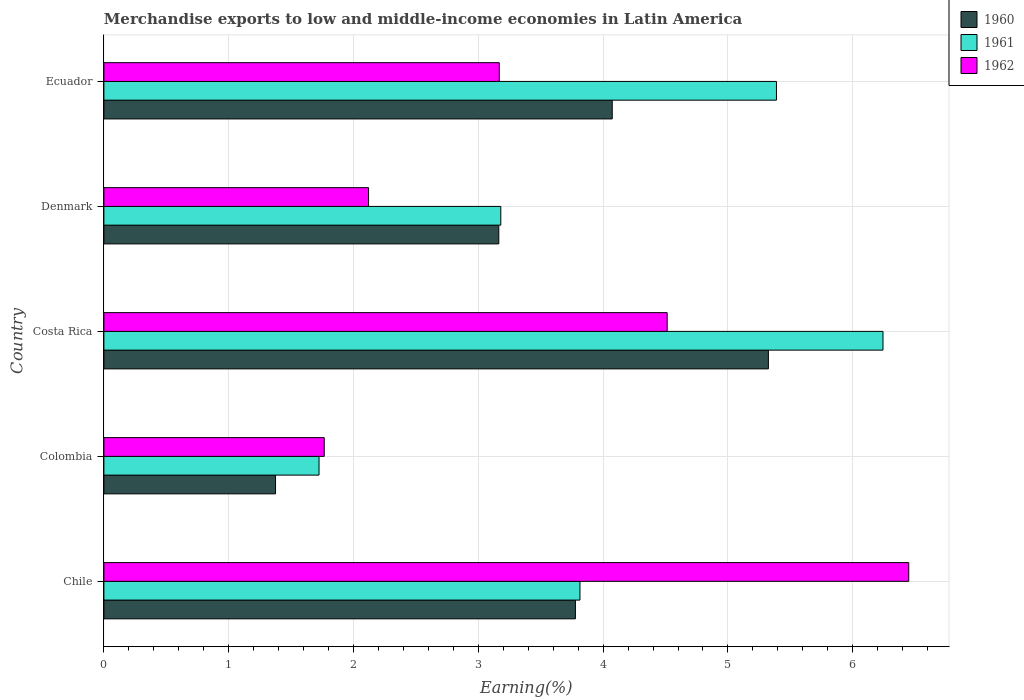How many different coloured bars are there?
Your response must be concise. 3. Are the number of bars on each tick of the Y-axis equal?
Keep it short and to the point. Yes. How many bars are there on the 3rd tick from the bottom?
Provide a succinct answer. 3. In how many cases, is the number of bars for a given country not equal to the number of legend labels?
Provide a short and direct response. 0. What is the percentage of amount earned from merchandise exports in 1962 in Chile?
Keep it short and to the point. 6.45. Across all countries, what is the maximum percentage of amount earned from merchandise exports in 1962?
Your answer should be very brief. 6.45. Across all countries, what is the minimum percentage of amount earned from merchandise exports in 1960?
Ensure brevity in your answer.  1.38. In which country was the percentage of amount earned from merchandise exports in 1962 maximum?
Your answer should be very brief. Chile. In which country was the percentage of amount earned from merchandise exports in 1961 minimum?
Your answer should be very brief. Colombia. What is the total percentage of amount earned from merchandise exports in 1960 in the graph?
Your answer should be compact. 17.71. What is the difference between the percentage of amount earned from merchandise exports in 1961 in Colombia and that in Costa Rica?
Your response must be concise. -4.52. What is the difference between the percentage of amount earned from merchandise exports in 1961 in Costa Rica and the percentage of amount earned from merchandise exports in 1962 in Ecuador?
Your response must be concise. 3.07. What is the average percentage of amount earned from merchandise exports in 1960 per country?
Your answer should be compact. 3.54. What is the difference between the percentage of amount earned from merchandise exports in 1962 and percentage of amount earned from merchandise exports in 1961 in Denmark?
Offer a terse response. -1.06. What is the ratio of the percentage of amount earned from merchandise exports in 1960 in Denmark to that in Ecuador?
Give a very brief answer. 0.78. Is the percentage of amount earned from merchandise exports in 1960 in Costa Rica less than that in Denmark?
Offer a terse response. No. Is the difference between the percentage of amount earned from merchandise exports in 1962 in Chile and Denmark greater than the difference between the percentage of amount earned from merchandise exports in 1961 in Chile and Denmark?
Offer a terse response. Yes. What is the difference between the highest and the second highest percentage of amount earned from merchandise exports in 1960?
Offer a terse response. 1.25. What is the difference between the highest and the lowest percentage of amount earned from merchandise exports in 1960?
Ensure brevity in your answer.  3.95. Is the sum of the percentage of amount earned from merchandise exports in 1962 in Denmark and Ecuador greater than the maximum percentage of amount earned from merchandise exports in 1960 across all countries?
Give a very brief answer. No. What does the 3rd bar from the top in Costa Rica represents?
Your response must be concise. 1960. What does the 2nd bar from the bottom in Colombia represents?
Keep it short and to the point. 1961. Is it the case that in every country, the sum of the percentage of amount earned from merchandise exports in 1960 and percentage of amount earned from merchandise exports in 1962 is greater than the percentage of amount earned from merchandise exports in 1961?
Provide a succinct answer. Yes. How many bars are there?
Offer a very short reply. 15. How many countries are there in the graph?
Make the answer very short. 5. Does the graph contain any zero values?
Ensure brevity in your answer.  No. Does the graph contain grids?
Give a very brief answer. Yes. Where does the legend appear in the graph?
Provide a succinct answer. Top right. What is the title of the graph?
Provide a succinct answer. Merchandise exports to low and middle-income economies in Latin America. What is the label or title of the X-axis?
Provide a succinct answer. Earning(%). What is the Earning(%) of 1960 in Chile?
Give a very brief answer. 3.78. What is the Earning(%) of 1961 in Chile?
Provide a succinct answer. 3.81. What is the Earning(%) of 1962 in Chile?
Provide a short and direct response. 6.45. What is the Earning(%) of 1960 in Colombia?
Provide a short and direct response. 1.38. What is the Earning(%) of 1961 in Colombia?
Provide a succinct answer. 1.72. What is the Earning(%) in 1962 in Colombia?
Offer a terse response. 1.77. What is the Earning(%) of 1960 in Costa Rica?
Give a very brief answer. 5.32. What is the Earning(%) in 1961 in Costa Rica?
Your answer should be compact. 6.24. What is the Earning(%) in 1962 in Costa Rica?
Your response must be concise. 4.51. What is the Earning(%) in 1960 in Denmark?
Offer a very short reply. 3.16. What is the Earning(%) of 1961 in Denmark?
Keep it short and to the point. 3.18. What is the Earning(%) of 1962 in Denmark?
Keep it short and to the point. 2.12. What is the Earning(%) of 1960 in Ecuador?
Offer a terse response. 4.07. What is the Earning(%) of 1961 in Ecuador?
Your answer should be very brief. 5.39. What is the Earning(%) of 1962 in Ecuador?
Provide a succinct answer. 3.17. Across all countries, what is the maximum Earning(%) in 1960?
Provide a succinct answer. 5.32. Across all countries, what is the maximum Earning(%) in 1961?
Your response must be concise. 6.24. Across all countries, what is the maximum Earning(%) of 1962?
Your answer should be compact. 6.45. Across all countries, what is the minimum Earning(%) in 1960?
Offer a very short reply. 1.38. Across all countries, what is the minimum Earning(%) of 1961?
Keep it short and to the point. 1.72. Across all countries, what is the minimum Earning(%) in 1962?
Offer a terse response. 1.77. What is the total Earning(%) in 1960 in the graph?
Offer a terse response. 17.71. What is the total Earning(%) in 1961 in the graph?
Ensure brevity in your answer.  20.35. What is the total Earning(%) of 1962 in the graph?
Ensure brevity in your answer.  18.02. What is the difference between the Earning(%) of 1960 in Chile and that in Colombia?
Provide a succinct answer. 2.4. What is the difference between the Earning(%) of 1961 in Chile and that in Colombia?
Offer a terse response. 2.09. What is the difference between the Earning(%) of 1962 in Chile and that in Colombia?
Provide a short and direct response. 4.68. What is the difference between the Earning(%) of 1960 in Chile and that in Costa Rica?
Your response must be concise. -1.55. What is the difference between the Earning(%) in 1961 in Chile and that in Costa Rica?
Offer a very short reply. -2.43. What is the difference between the Earning(%) in 1962 in Chile and that in Costa Rica?
Your answer should be very brief. 1.94. What is the difference between the Earning(%) of 1960 in Chile and that in Denmark?
Your answer should be very brief. 0.61. What is the difference between the Earning(%) of 1961 in Chile and that in Denmark?
Give a very brief answer. 0.63. What is the difference between the Earning(%) in 1962 in Chile and that in Denmark?
Offer a very short reply. 4.33. What is the difference between the Earning(%) of 1960 in Chile and that in Ecuador?
Your answer should be compact. -0.3. What is the difference between the Earning(%) of 1961 in Chile and that in Ecuador?
Provide a succinct answer. -1.57. What is the difference between the Earning(%) in 1962 in Chile and that in Ecuador?
Provide a short and direct response. 3.28. What is the difference between the Earning(%) in 1960 in Colombia and that in Costa Rica?
Give a very brief answer. -3.95. What is the difference between the Earning(%) of 1961 in Colombia and that in Costa Rica?
Ensure brevity in your answer.  -4.52. What is the difference between the Earning(%) of 1962 in Colombia and that in Costa Rica?
Your answer should be compact. -2.75. What is the difference between the Earning(%) in 1960 in Colombia and that in Denmark?
Your answer should be very brief. -1.79. What is the difference between the Earning(%) in 1961 in Colombia and that in Denmark?
Provide a succinct answer. -1.46. What is the difference between the Earning(%) of 1962 in Colombia and that in Denmark?
Your response must be concise. -0.36. What is the difference between the Earning(%) of 1960 in Colombia and that in Ecuador?
Your answer should be very brief. -2.7. What is the difference between the Earning(%) in 1961 in Colombia and that in Ecuador?
Provide a short and direct response. -3.66. What is the difference between the Earning(%) of 1962 in Colombia and that in Ecuador?
Give a very brief answer. -1.4. What is the difference between the Earning(%) in 1960 in Costa Rica and that in Denmark?
Offer a very short reply. 2.16. What is the difference between the Earning(%) in 1961 in Costa Rica and that in Denmark?
Your response must be concise. 3.06. What is the difference between the Earning(%) of 1962 in Costa Rica and that in Denmark?
Your response must be concise. 2.39. What is the difference between the Earning(%) of 1960 in Costa Rica and that in Ecuador?
Make the answer very short. 1.25. What is the difference between the Earning(%) in 1961 in Costa Rica and that in Ecuador?
Give a very brief answer. 0.85. What is the difference between the Earning(%) of 1962 in Costa Rica and that in Ecuador?
Offer a terse response. 1.35. What is the difference between the Earning(%) of 1960 in Denmark and that in Ecuador?
Offer a terse response. -0.91. What is the difference between the Earning(%) in 1961 in Denmark and that in Ecuador?
Provide a succinct answer. -2.21. What is the difference between the Earning(%) in 1962 in Denmark and that in Ecuador?
Provide a short and direct response. -1.05. What is the difference between the Earning(%) in 1960 in Chile and the Earning(%) in 1961 in Colombia?
Your answer should be very brief. 2.05. What is the difference between the Earning(%) of 1960 in Chile and the Earning(%) of 1962 in Colombia?
Give a very brief answer. 2.01. What is the difference between the Earning(%) of 1961 in Chile and the Earning(%) of 1962 in Colombia?
Keep it short and to the point. 2.05. What is the difference between the Earning(%) of 1960 in Chile and the Earning(%) of 1961 in Costa Rica?
Your answer should be compact. -2.46. What is the difference between the Earning(%) of 1960 in Chile and the Earning(%) of 1962 in Costa Rica?
Provide a short and direct response. -0.74. What is the difference between the Earning(%) in 1961 in Chile and the Earning(%) in 1962 in Costa Rica?
Offer a terse response. -0.7. What is the difference between the Earning(%) in 1960 in Chile and the Earning(%) in 1961 in Denmark?
Your answer should be very brief. 0.6. What is the difference between the Earning(%) in 1960 in Chile and the Earning(%) in 1962 in Denmark?
Offer a very short reply. 1.66. What is the difference between the Earning(%) in 1961 in Chile and the Earning(%) in 1962 in Denmark?
Provide a succinct answer. 1.69. What is the difference between the Earning(%) in 1960 in Chile and the Earning(%) in 1961 in Ecuador?
Provide a short and direct response. -1.61. What is the difference between the Earning(%) of 1960 in Chile and the Earning(%) of 1962 in Ecuador?
Ensure brevity in your answer.  0.61. What is the difference between the Earning(%) in 1961 in Chile and the Earning(%) in 1962 in Ecuador?
Make the answer very short. 0.65. What is the difference between the Earning(%) in 1960 in Colombia and the Earning(%) in 1961 in Costa Rica?
Make the answer very short. -4.87. What is the difference between the Earning(%) of 1960 in Colombia and the Earning(%) of 1962 in Costa Rica?
Give a very brief answer. -3.14. What is the difference between the Earning(%) of 1961 in Colombia and the Earning(%) of 1962 in Costa Rica?
Offer a terse response. -2.79. What is the difference between the Earning(%) in 1960 in Colombia and the Earning(%) in 1961 in Denmark?
Keep it short and to the point. -1.8. What is the difference between the Earning(%) in 1960 in Colombia and the Earning(%) in 1962 in Denmark?
Your answer should be very brief. -0.75. What is the difference between the Earning(%) of 1961 in Colombia and the Earning(%) of 1962 in Denmark?
Keep it short and to the point. -0.4. What is the difference between the Earning(%) of 1960 in Colombia and the Earning(%) of 1961 in Ecuador?
Keep it short and to the point. -4.01. What is the difference between the Earning(%) of 1960 in Colombia and the Earning(%) of 1962 in Ecuador?
Ensure brevity in your answer.  -1.79. What is the difference between the Earning(%) of 1961 in Colombia and the Earning(%) of 1962 in Ecuador?
Your answer should be very brief. -1.44. What is the difference between the Earning(%) in 1960 in Costa Rica and the Earning(%) in 1961 in Denmark?
Give a very brief answer. 2.14. What is the difference between the Earning(%) of 1960 in Costa Rica and the Earning(%) of 1962 in Denmark?
Your response must be concise. 3.2. What is the difference between the Earning(%) in 1961 in Costa Rica and the Earning(%) in 1962 in Denmark?
Your answer should be very brief. 4.12. What is the difference between the Earning(%) in 1960 in Costa Rica and the Earning(%) in 1961 in Ecuador?
Offer a terse response. -0.06. What is the difference between the Earning(%) of 1960 in Costa Rica and the Earning(%) of 1962 in Ecuador?
Provide a short and direct response. 2.16. What is the difference between the Earning(%) in 1961 in Costa Rica and the Earning(%) in 1962 in Ecuador?
Offer a very short reply. 3.07. What is the difference between the Earning(%) in 1960 in Denmark and the Earning(%) in 1961 in Ecuador?
Keep it short and to the point. -2.22. What is the difference between the Earning(%) in 1960 in Denmark and the Earning(%) in 1962 in Ecuador?
Provide a short and direct response. -0. What is the difference between the Earning(%) in 1961 in Denmark and the Earning(%) in 1962 in Ecuador?
Your response must be concise. 0.01. What is the average Earning(%) of 1960 per country?
Your answer should be very brief. 3.54. What is the average Earning(%) of 1961 per country?
Your answer should be very brief. 4.07. What is the average Earning(%) in 1962 per country?
Offer a very short reply. 3.6. What is the difference between the Earning(%) in 1960 and Earning(%) in 1961 in Chile?
Provide a succinct answer. -0.04. What is the difference between the Earning(%) in 1960 and Earning(%) in 1962 in Chile?
Your answer should be very brief. -2.67. What is the difference between the Earning(%) of 1961 and Earning(%) of 1962 in Chile?
Offer a very short reply. -2.63. What is the difference between the Earning(%) of 1960 and Earning(%) of 1961 in Colombia?
Provide a short and direct response. -0.35. What is the difference between the Earning(%) in 1960 and Earning(%) in 1962 in Colombia?
Your answer should be very brief. -0.39. What is the difference between the Earning(%) in 1961 and Earning(%) in 1962 in Colombia?
Offer a very short reply. -0.04. What is the difference between the Earning(%) of 1960 and Earning(%) of 1961 in Costa Rica?
Your answer should be very brief. -0.92. What is the difference between the Earning(%) of 1960 and Earning(%) of 1962 in Costa Rica?
Provide a succinct answer. 0.81. What is the difference between the Earning(%) of 1961 and Earning(%) of 1962 in Costa Rica?
Offer a terse response. 1.73. What is the difference between the Earning(%) of 1960 and Earning(%) of 1961 in Denmark?
Your response must be concise. -0.02. What is the difference between the Earning(%) of 1960 and Earning(%) of 1962 in Denmark?
Keep it short and to the point. 1.04. What is the difference between the Earning(%) of 1961 and Earning(%) of 1962 in Denmark?
Offer a very short reply. 1.06. What is the difference between the Earning(%) in 1960 and Earning(%) in 1961 in Ecuador?
Your response must be concise. -1.32. What is the difference between the Earning(%) in 1960 and Earning(%) in 1962 in Ecuador?
Offer a terse response. 0.91. What is the difference between the Earning(%) of 1961 and Earning(%) of 1962 in Ecuador?
Give a very brief answer. 2.22. What is the ratio of the Earning(%) of 1960 in Chile to that in Colombia?
Your answer should be very brief. 2.75. What is the ratio of the Earning(%) in 1961 in Chile to that in Colombia?
Keep it short and to the point. 2.21. What is the ratio of the Earning(%) of 1962 in Chile to that in Colombia?
Offer a very short reply. 3.65. What is the ratio of the Earning(%) of 1960 in Chile to that in Costa Rica?
Provide a succinct answer. 0.71. What is the ratio of the Earning(%) in 1961 in Chile to that in Costa Rica?
Offer a terse response. 0.61. What is the ratio of the Earning(%) of 1962 in Chile to that in Costa Rica?
Your answer should be very brief. 1.43. What is the ratio of the Earning(%) in 1960 in Chile to that in Denmark?
Offer a very short reply. 1.19. What is the ratio of the Earning(%) in 1961 in Chile to that in Denmark?
Provide a succinct answer. 1.2. What is the ratio of the Earning(%) of 1962 in Chile to that in Denmark?
Provide a succinct answer. 3.04. What is the ratio of the Earning(%) of 1960 in Chile to that in Ecuador?
Give a very brief answer. 0.93. What is the ratio of the Earning(%) in 1961 in Chile to that in Ecuador?
Offer a terse response. 0.71. What is the ratio of the Earning(%) in 1962 in Chile to that in Ecuador?
Ensure brevity in your answer.  2.04. What is the ratio of the Earning(%) of 1960 in Colombia to that in Costa Rica?
Ensure brevity in your answer.  0.26. What is the ratio of the Earning(%) of 1961 in Colombia to that in Costa Rica?
Offer a terse response. 0.28. What is the ratio of the Earning(%) in 1962 in Colombia to that in Costa Rica?
Your answer should be compact. 0.39. What is the ratio of the Earning(%) in 1960 in Colombia to that in Denmark?
Your answer should be compact. 0.43. What is the ratio of the Earning(%) of 1961 in Colombia to that in Denmark?
Give a very brief answer. 0.54. What is the ratio of the Earning(%) of 1962 in Colombia to that in Denmark?
Your answer should be very brief. 0.83. What is the ratio of the Earning(%) of 1960 in Colombia to that in Ecuador?
Ensure brevity in your answer.  0.34. What is the ratio of the Earning(%) of 1961 in Colombia to that in Ecuador?
Give a very brief answer. 0.32. What is the ratio of the Earning(%) of 1962 in Colombia to that in Ecuador?
Give a very brief answer. 0.56. What is the ratio of the Earning(%) of 1960 in Costa Rica to that in Denmark?
Your answer should be compact. 1.68. What is the ratio of the Earning(%) in 1961 in Costa Rica to that in Denmark?
Your answer should be compact. 1.96. What is the ratio of the Earning(%) of 1962 in Costa Rica to that in Denmark?
Your response must be concise. 2.13. What is the ratio of the Earning(%) of 1960 in Costa Rica to that in Ecuador?
Offer a very short reply. 1.31. What is the ratio of the Earning(%) in 1961 in Costa Rica to that in Ecuador?
Keep it short and to the point. 1.16. What is the ratio of the Earning(%) in 1962 in Costa Rica to that in Ecuador?
Ensure brevity in your answer.  1.42. What is the ratio of the Earning(%) of 1960 in Denmark to that in Ecuador?
Your answer should be very brief. 0.78. What is the ratio of the Earning(%) of 1961 in Denmark to that in Ecuador?
Your answer should be very brief. 0.59. What is the ratio of the Earning(%) of 1962 in Denmark to that in Ecuador?
Your answer should be very brief. 0.67. What is the difference between the highest and the second highest Earning(%) of 1960?
Your response must be concise. 1.25. What is the difference between the highest and the second highest Earning(%) of 1961?
Offer a very short reply. 0.85. What is the difference between the highest and the second highest Earning(%) in 1962?
Your answer should be compact. 1.94. What is the difference between the highest and the lowest Earning(%) in 1960?
Offer a very short reply. 3.95. What is the difference between the highest and the lowest Earning(%) of 1961?
Your answer should be compact. 4.52. What is the difference between the highest and the lowest Earning(%) of 1962?
Provide a succinct answer. 4.68. 